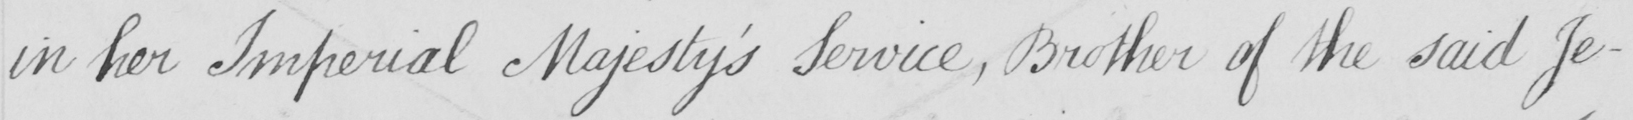What text is written in this handwritten line? in her Imperial Majesty ' s Service , Brother of the said Je- 